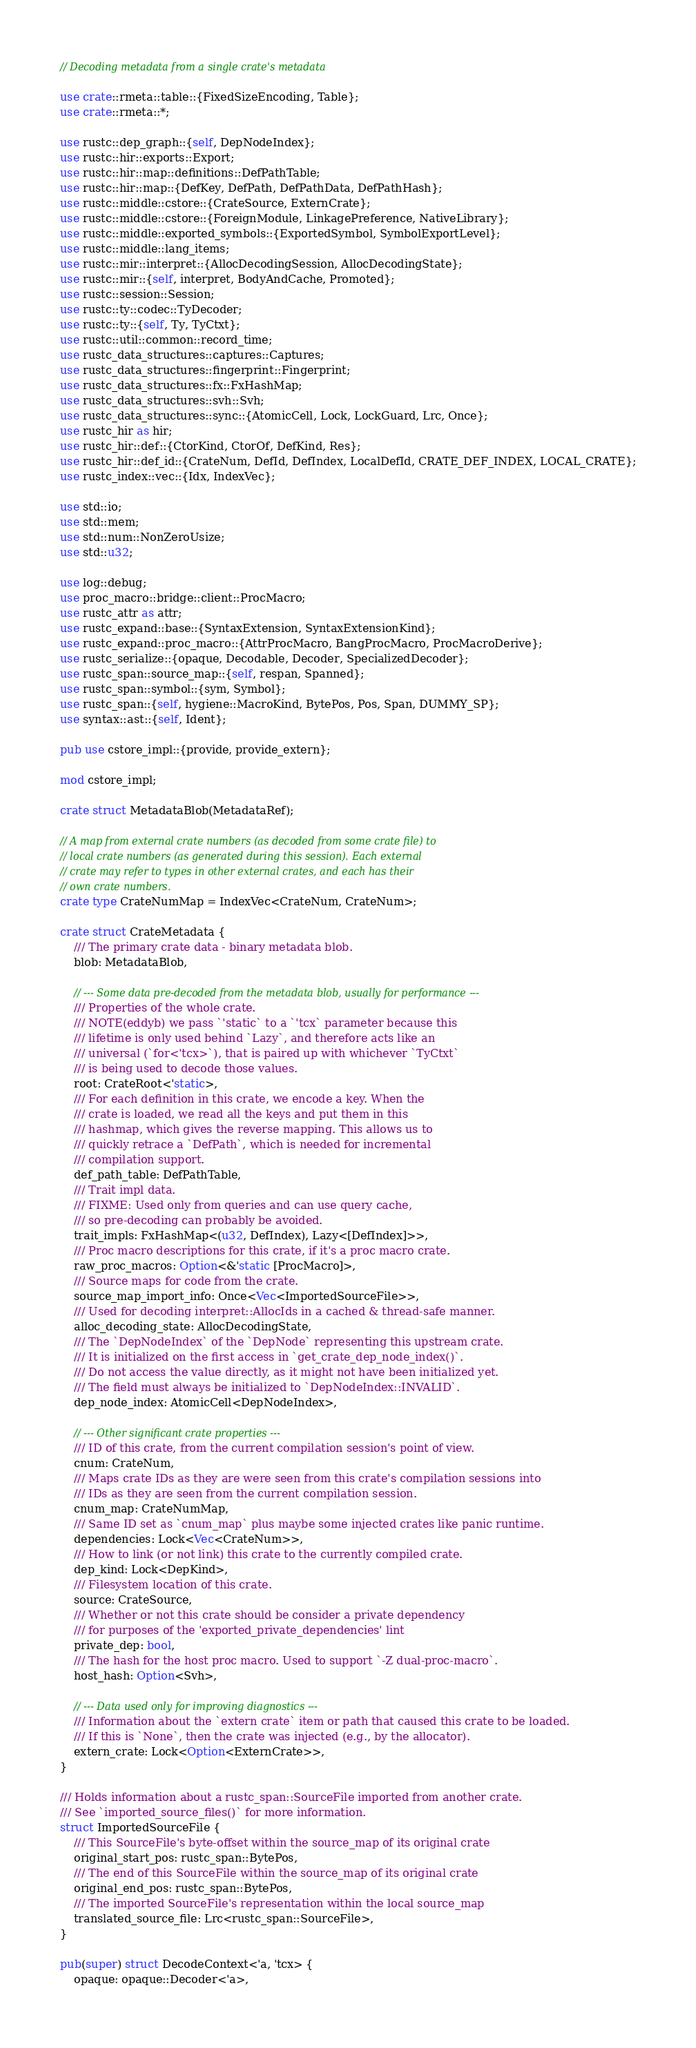Convert code to text. <code><loc_0><loc_0><loc_500><loc_500><_Rust_>// Decoding metadata from a single crate's metadata

use crate::rmeta::table::{FixedSizeEncoding, Table};
use crate::rmeta::*;

use rustc::dep_graph::{self, DepNodeIndex};
use rustc::hir::exports::Export;
use rustc::hir::map::definitions::DefPathTable;
use rustc::hir::map::{DefKey, DefPath, DefPathData, DefPathHash};
use rustc::middle::cstore::{CrateSource, ExternCrate};
use rustc::middle::cstore::{ForeignModule, LinkagePreference, NativeLibrary};
use rustc::middle::exported_symbols::{ExportedSymbol, SymbolExportLevel};
use rustc::middle::lang_items;
use rustc::mir::interpret::{AllocDecodingSession, AllocDecodingState};
use rustc::mir::{self, interpret, BodyAndCache, Promoted};
use rustc::session::Session;
use rustc::ty::codec::TyDecoder;
use rustc::ty::{self, Ty, TyCtxt};
use rustc::util::common::record_time;
use rustc_data_structures::captures::Captures;
use rustc_data_structures::fingerprint::Fingerprint;
use rustc_data_structures::fx::FxHashMap;
use rustc_data_structures::svh::Svh;
use rustc_data_structures::sync::{AtomicCell, Lock, LockGuard, Lrc, Once};
use rustc_hir as hir;
use rustc_hir::def::{CtorKind, CtorOf, DefKind, Res};
use rustc_hir::def_id::{CrateNum, DefId, DefIndex, LocalDefId, CRATE_DEF_INDEX, LOCAL_CRATE};
use rustc_index::vec::{Idx, IndexVec};

use std::io;
use std::mem;
use std::num::NonZeroUsize;
use std::u32;

use log::debug;
use proc_macro::bridge::client::ProcMacro;
use rustc_attr as attr;
use rustc_expand::base::{SyntaxExtension, SyntaxExtensionKind};
use rustc_expand::proc_macro::{AttrProcMacro, BangProcMacro, ProcMacroDerive};
use rustc_serialize::{opaque, Decodable, Decoder, SpecializedDecoder};
use rustc_span::source_map::{self, respan, Spanned};
use rustc_span::symbol::{sym, Symbol};
use rustc_span::{self, hygiene::MacroKind, BytePos, Pos, Span, DUMMY_SP};
use syntax::ast::{self, Ident};

pub use cstore_impl::{provide, provide_extern};

mod cstore_impl;

crate struct MetadataBlob(MetadataRef);

// A map from external crate numbers (as decoded from some crate file) to
// local crate numbers (as generated during this session). Each external
// crate may refer to types in other external crates, and each has their
// own crate numbers.
crate type CrateNumMap = IndexVec<CrateNum, CrateNum>;

crate struct CrateMetadata {
    /// The primary crate data - binary metadata blob.
    blob: MetadataBlob,

    // --- Some data pre-decoded from the metadata blob, usually for performance ---
    /// Properties of the whole crate.
    /// NOTE(eddyb) we pass `'static` to a `'tcx` parameter because this
    /// lifetime is only used behind `Lazy`, and therefore acts like an
    /// universal (`for<'tcx>`), that is paired up with whichever `TyCtxt`
    /// is being used to decode those values.
    root: CrateRoot<'static>,
    /// For each definition in this crate, we encode a key. When the
    /// crate is loaded, we read all the keys and put them in this
    /// hashmap, which gives the reverse mapping. This allows us to
    /// quickly retrace a `DefPath`, which is needed for incremental
    /// compilation support.
    def_path_table: DefPathTable,
    /// Trait impl data.
    /// FIXME: Used only from queries and can use query cache,
    /// so pre-decoding can probably be avoided.
    trait_impls: FxHashMap<(u32, DefIndex), Lazy<[DefIndex]>>,
    /// Proc macro descriptions for this crate, if it's a proc macro crate.
    raw_proc_macros: Option<&'static [ProcMacro]>,
    /// Source maps for code from the crate.
    source_map_import_info: Once<Vec<ImportedSourceFile>>,
    /// Used for decoding interpret::AllocIds in a cached & thread-safe manner.
    alloc_decoding_state: AllocDecodingState,
    /// The `DepNodeIndex` of the `DepNode` representing this upstream crate.
    /// It is initialized on the first access in `get_crate_dep_node_index()`.
    /// Do not access the value directly, as it might not have been initialized yet.
    /// The field must always be initialized to `DepNodeIndex::INVALID`.
    dep_node_index: AtomicCell<DepNodeIndex>,

    // --- Other significant crate properties ---
    /// ID of this crate, from the current compilation session's point of view.
    cnum: CrateNum,
    /// Maps crate IDs as they are were seen from this crate's compilation sessions into
    /// IDs as they are seen from the current compilation session.
    cnum_map: CrateNumMap,
    /// Same ID set as `cnum_map` plus maybe some injected crates like panic runtime.
    dependencies: Lock<Vec<CrateNum>>,
    /// How to link (or not link) this crate to the currently compiled crate.
    dep_kind: Lock<DepKind>,
    /// Filesystem location of this crate.
    source: CrateSource,
    /// Whether or not this crate should be consider a private dependency
    /// for purposes of the 'exported_private_dependencies' lint
    private_dep: bool,
    /// The hash for the host proc macro. Used to support `-Z dual-proc-macro`.
    host_hash: Option<Svh>,

    // --- Data used only for improving diagnostics ---
    /// Information about the `extern crate` item or path that caused this crate to be loaded.
    /// If this is `None`, then the crate was injected (e.g., by the allocator).
    extern_crate: Lock<Option<ExternCrate>>,
}

/// Holds information about a rustc_span::SourceFile imported from another crate.
/// See `imported_source_files()` for more information.
struct ImportedSourceFile {
    /// This SourceFile's byte-offset within the source_map of its original crate
    original_start_pos: rustc_span::BytePos,
    /// The end of this SourceFile within the source_map of its original crate
    original_end_pos: rustc_span::BytePos,
    /// The imported SourceFile's representation within the local source_map
    translated_source_file: Lrc<rustc_span::SourceFile>,
}

pub(super) struct DecodeContext<'a, 'tcx> {
    opaque: opaque::Decoder<'a>,</code> 